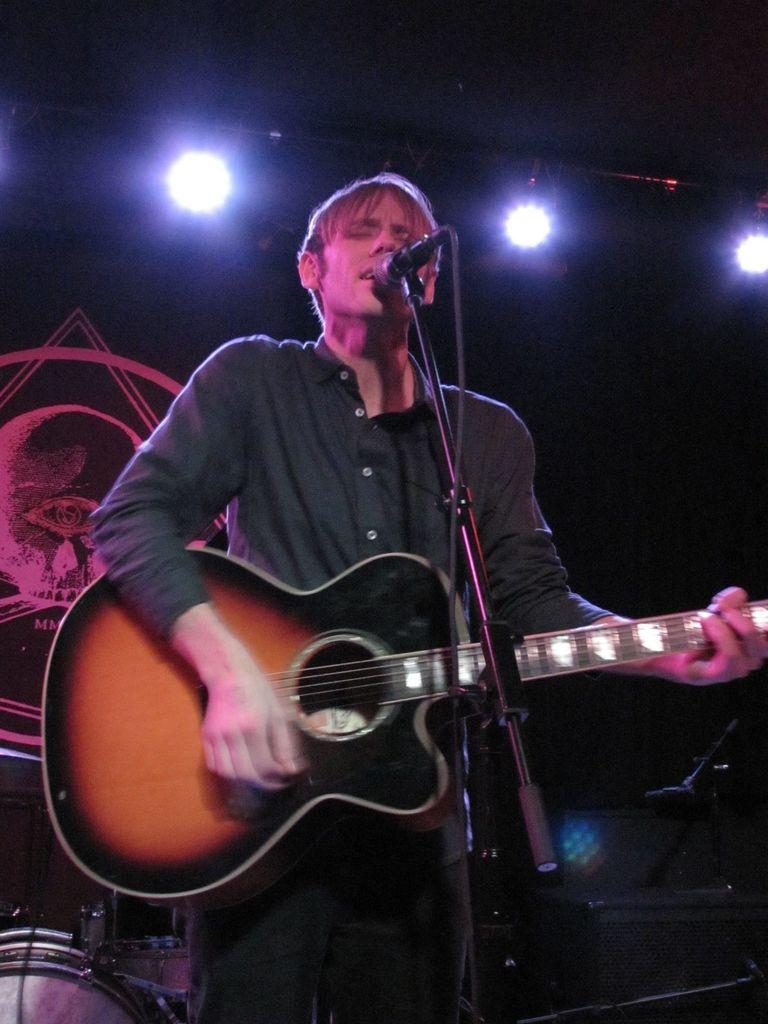What is the person in the image doing? The person is standing in the image and holding a guitar. What object is in front of the person? There is a microphone in front of the person. What can be seen in the background of the image? There are lights, a wall, and musical instruments visible in the background. What type of oil is being used by the laborer in the image? There is no laborer or oil present in the image. How old is the boy in the image? There is no boy present in the image. 